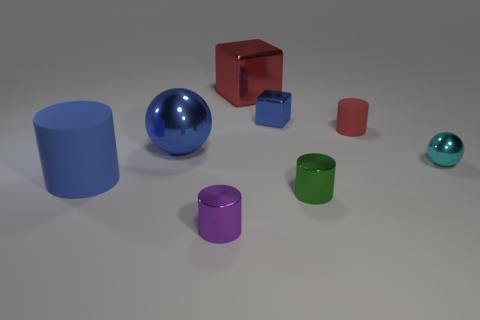Subtract all tiny cylinders. How many cylinders are left? 1 Add 1 tiny green cylinders. How many objects exist? 9 Subtract all blue cylinders. How many cylinders are left? 3 Subtract 1 cylinders. How many cylinders are left? 3 Subtract all cubes. How many objects are left? 6 Subtract all blue spheres. Subtract all cyan cubes. How many spheres are left? 1 Subtract all yellow spheres. How many red cubes are left? 1 Subtract all tiny blue balls. Subtract all red matte things. How many objects are left? 7 Add 3 matte cylinders. How many matte cylinders are left? 5 Add 2 shiny cylinders. How many shiny cylinders exist? 4 